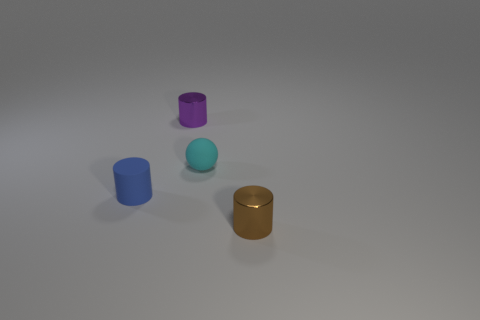Does the cyan object have the same size as the rubber thing in front of the small cyan matte ball?
Keep it short and to the point. Yes. What number of cylinders are either shiny objects or blue matte objects?
Make the answer very short. 3. How many things are both right of the tiny purple metal thing and in front of the cyan rubber sphere?
Your answer should be very brief. 1. What number of other things are the same color as the matte cylinder?
Ensure brevity in your answer.  0. What shape is the rubber thing that is behind the blue matte cylinder?
Make the answer very short. Sphere. Are the blue cylinder and the small purple thing made of the same material?
Give a very brief answer. No. There is a small cyan sphere; how many small shiny cylinders are behind it?
Make the answer very short. 1. The tiny cyan rubber object on the right side of the small metallic object on the left side of the brown thing is what shape?
Provide a succinct answer. Sphere. Is there anything else that has the same shape as the tiny brown thing?
Provide a short and direct response. Yes. Are there more tiny brown cylinders behind the tiny blue cylinder than large yellow shiny spheres?
Give a very brief answer. No. 